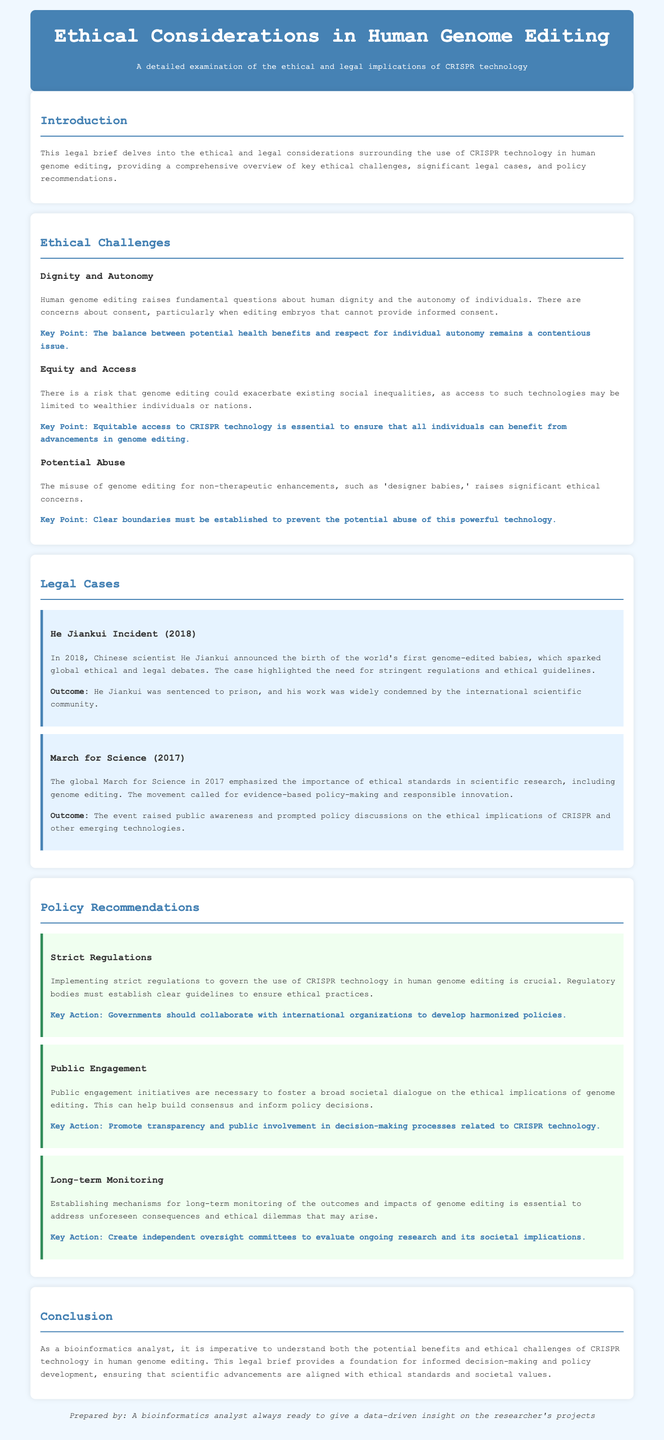What year did the He Jiankui incident occur? The He Jiankui incident is mentioned in the legal brief and occurred in 2018.
Answer: 2018 What are the key ethical issues highlighted in the document? The document highlights dignity and autonomy, equity and access, and potential abuse as key ethical issues in genome editing.
Answer: Dignity and autonomy, equity and access, potential abuse What was the outcome of the He Jiankui incident? The outcome states that He Jiankui was sentenced to prison and his work was condemned by the international scientific community.
Answer: He Jiankui was sentenced to prison What is a key action recommended for strict regulations? The document recommends that governments should collaborate with international organizations to develop harmonized policies as a key action.
Answer: Collaborate with international organizations What is one of the reasons for public engagement initiatives? The document states that public engagement initiatives are necessary to foster a broad societal dialogue on the ethical implications of genome editing.
Answer: Foster societal dialogue Which landmark case emphasized ethical standards in scientific research? The March for Science in 2017 is cited in the document as a landmark case that emphasized the importance of ethical standards in scientific research.
Answer: March for Science What is the main focus of this legal brief? The legal brief focuses on examining the ethical and legal implications of CRISPR technology in human genome editing.
Answer: Ethical and legal implications What is a proposed key action for long-term monitoring? The document proposes creating independent oversight committees to evaluate ongoing research and its societal implications as a key action for long-term monitoring.
Answer: Create independent oversight committees 